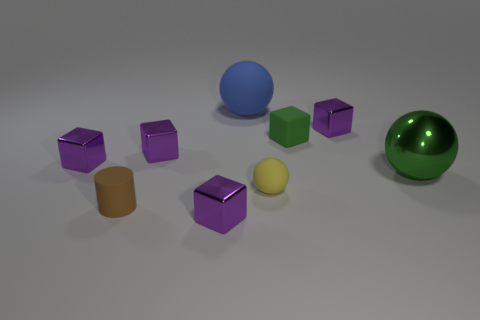Subtract all green balls. How many purple blocks are left? 4 Subtract 3 blocks. How many blocks are left? 2 Subtract all green cubes. How many cubes are left? 4 Subtract all tiny rubber blocks. How many blocks are left? 4 Add 1 blocks. How many objects exist? 10 Subtract all cyan cubes. Subtract all brown spheres. How many cubes are left? 5 Subtract all cylinders. How many objects are left? 8 Add 4 blue objects. How many blue objects are left? 5 Add 1 tiny green objects. How many tiny green objects exist? 2 Subtract 1 green balls. How many objects are left? 8 